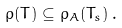<formula> <loc_0><loc_0><loc_500><loc_500>\rho ( T ) \subseteq \rho _ { A } ( T _ { s } ) \, .</formula> 